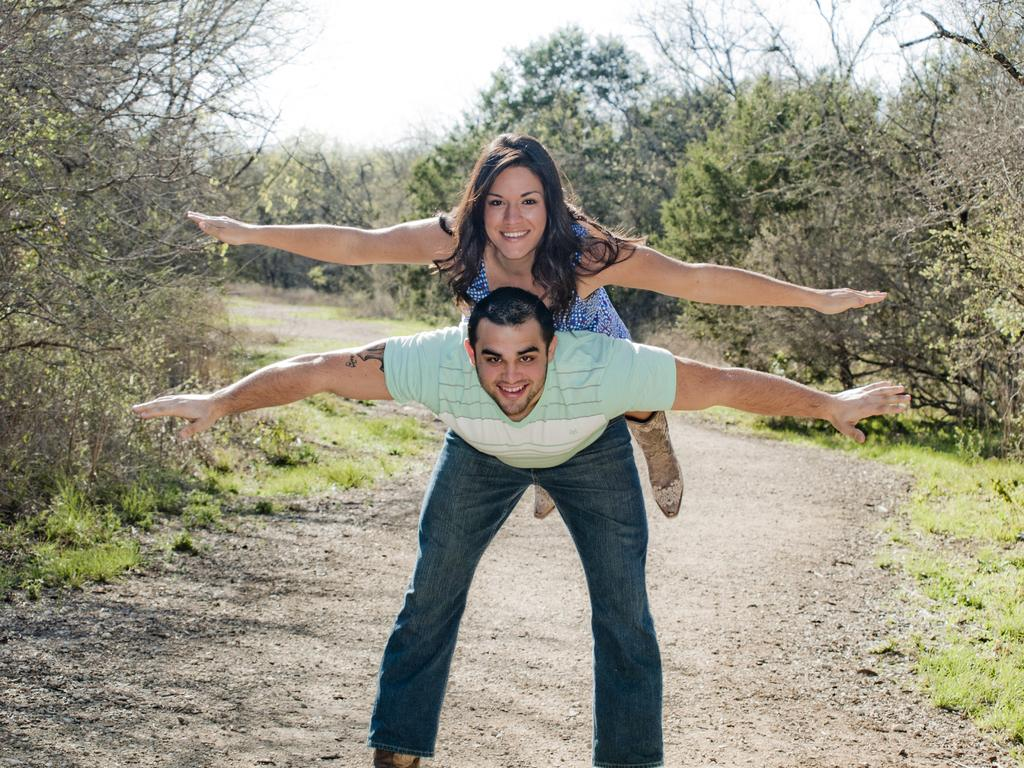How many people are in the image? There are two people in the image, a woman and a man. What is the woman doing in relation to the man? The woman is on the man. What type of natural environment is visible in the background of the image? There is visible in the background of the image. What is visible at the top of the image? The sky is visible at the top of the image. What type of mask is the woman wearing in the image? There is no mask present in the image; the woman is not wearing any mask. 